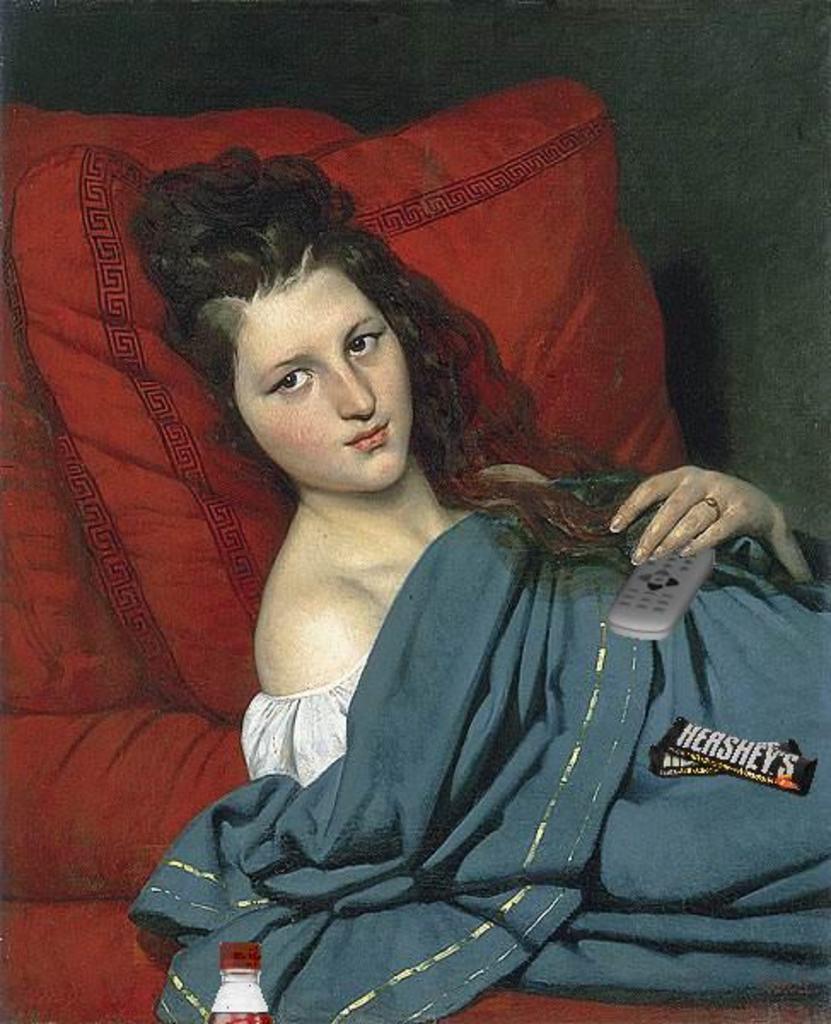Could you give a brief overview of what you see in this image? In this picture we can see a painting of a woman, she is holding remote and we can see blanket, red color couch with pillow along with bottle. 